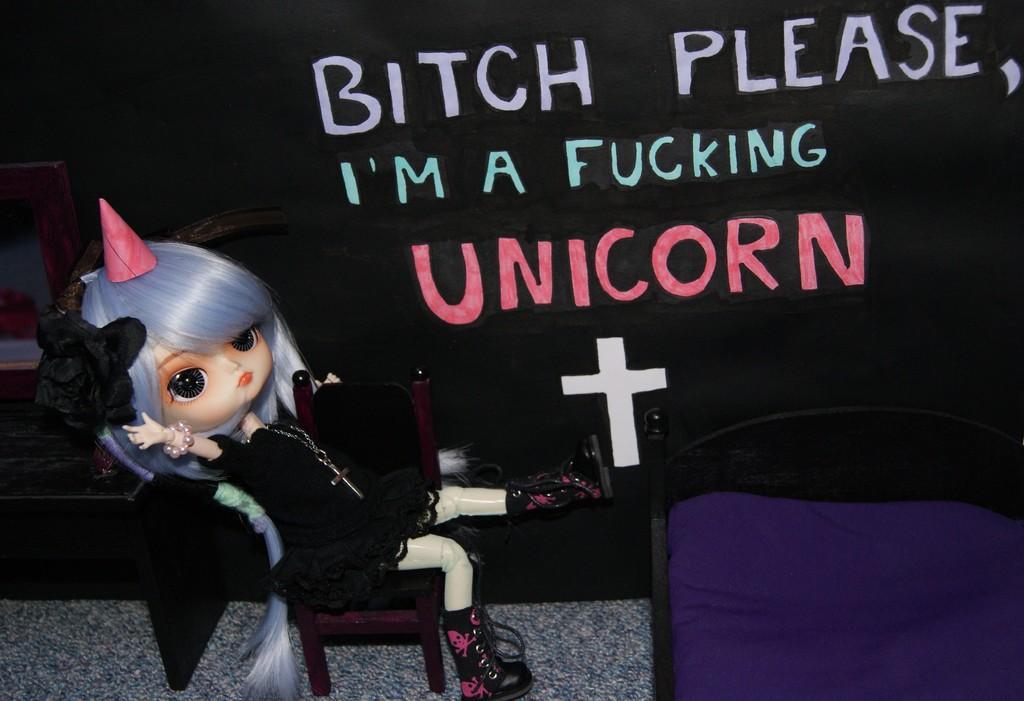How would you summarize this image in a sentence or two? In this image there is a toy, there is an object truncated towards the bottom of the image, there is an object truncated towards the left of the image, at the background of the image there is a cloth truncated, there is text on the cloth. 